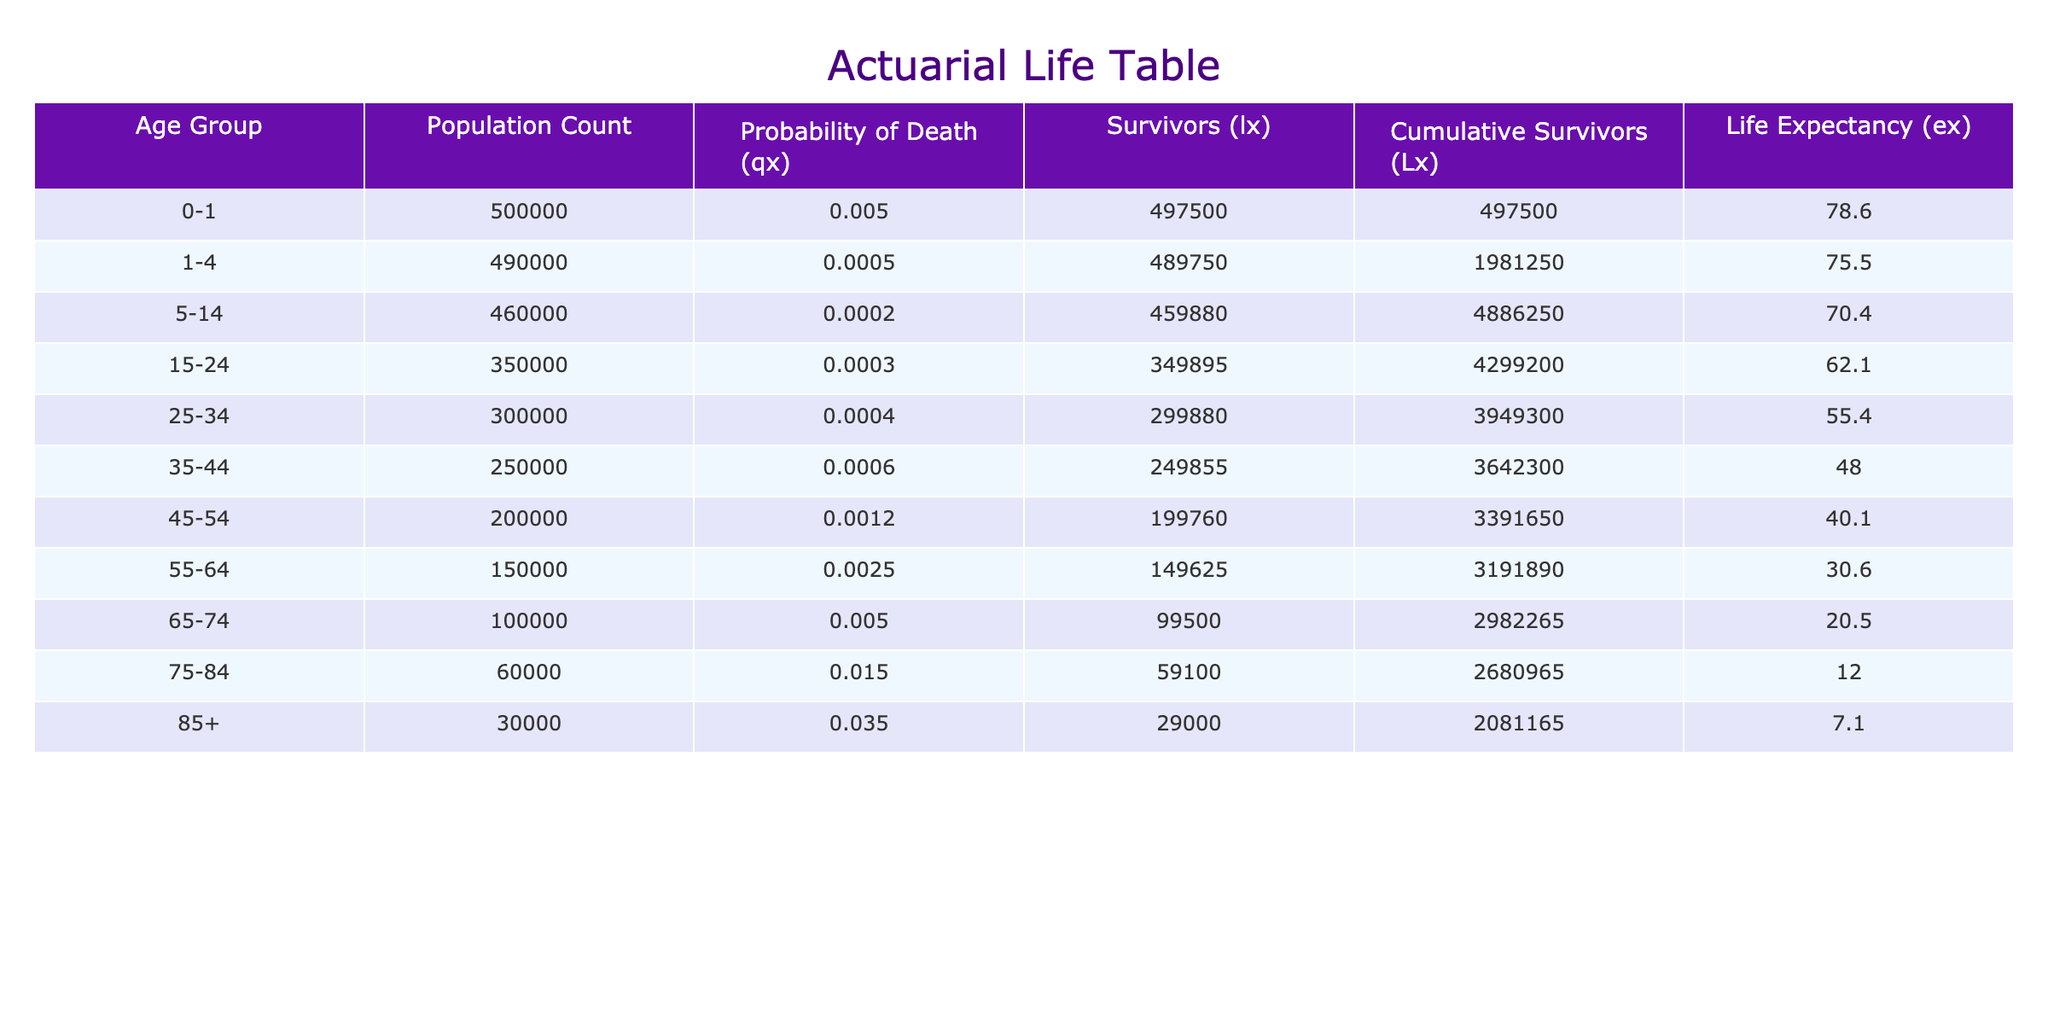What is the probability of death for the age group 55-64? The table lists the "Probability of Death (qx)" for different age groups. For the age group 55-64, the value is 0.0025.
Answer: 0.0025 What is the life expectancy for someone aged 65-74? The "Life Expectancy (ex)" column provides the life expectancy values for each age group. For the age group 65-74, it is 20.5 years.
Answer: 20.5 Which age group has the highest number of survivors (lx)? Looking at the "Survivors (lx)" column, the age group 0-1 has 497500 survivors, which is the highest compared to other age groups.
Answer: 0-1 What is the cumulative survivors for the age group 45-54? The cumulative survivors (Lx) for the age group 45-54 can be found in the respective column. The value is 3391650.
Answer: 3391650 Is the life expectancy for the age group 75-84 greater than 10 years? From the "Life Expectancy (ex)" column, the value for the age group 75-84 is 12.0 years, which is greater than 10 years, making this statement true.
Answer: Yes What is the average probability of death for the age groups 0-1, 1-4, and 5-14? First, identify the probabilities of death for the three age groups: 0.005, 0.0005, and 0.0002. Then calculate the average by summing these values: (0.005 + 0.0005 + 0.0002) = 0.0057. Since there are 3 groups, divide the total by 3: 0.0057 / 3 = 0.0019.
Answer: 0.0019 What is the difference in life expectancy between the age groups 25-34 and 45-54? The life expectancy for 25-34 is 55.4 years, and for 45-54 it is 40.1 years. To find the difference, subtract: 55.4 - 40.1 = 15.3 years.
Answer: 15.3 Which age group has the lowest probability of death? By examining the "Probability of Death (qx)" column, the age group 1-4 has a value of 0.0005, which is the lowest among all groups listed.
Answer: 1-4 For the age group 85+, how many survivors are there? The "Survivors (lx)" value for the age group 85+ is listed in the table as 29000, providing the precise number of survivors in that age group.
Answer: 29000 